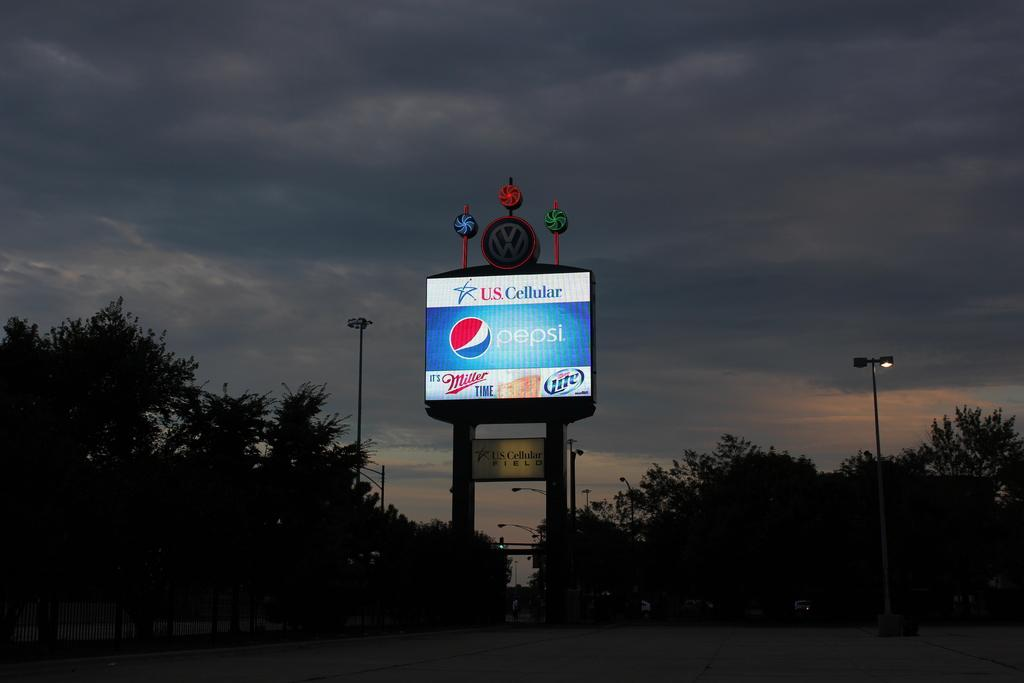<image>
Describe the image concisely. A sign for Pepsi and US Cellular is lit up against a dark night sky. 